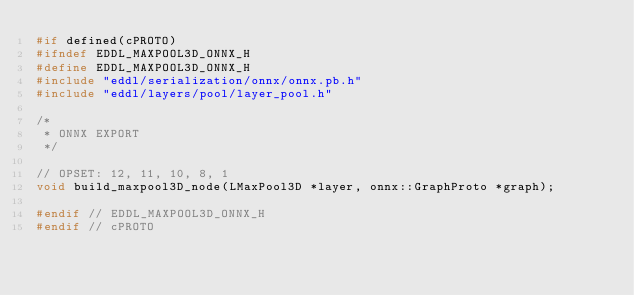Convert code to text. <code><loc_0><loc_0><loc_500><loc_500><_C_>#if defined(cPROTO)
#ifndef EDDL_MAXPOOL3D_ONNX_H
#define EDDL_MAXPOOL3D_ONNX_H
#include "eddl/serialization/onnx/onnx.pb.h"
#include "eddl/layers/pool/layer_pool.h"

/*
 * ONNX EXPORT
 */

// OPSET: 12, 11, 10, 8, 1
void build_maxpool3D_node(LMaxPool3D *layer, onnx::GraphProto *graph);

#endif // EDDL_MAXPOOL3D_ONNX_H
#endif // cPROTO
</code> 